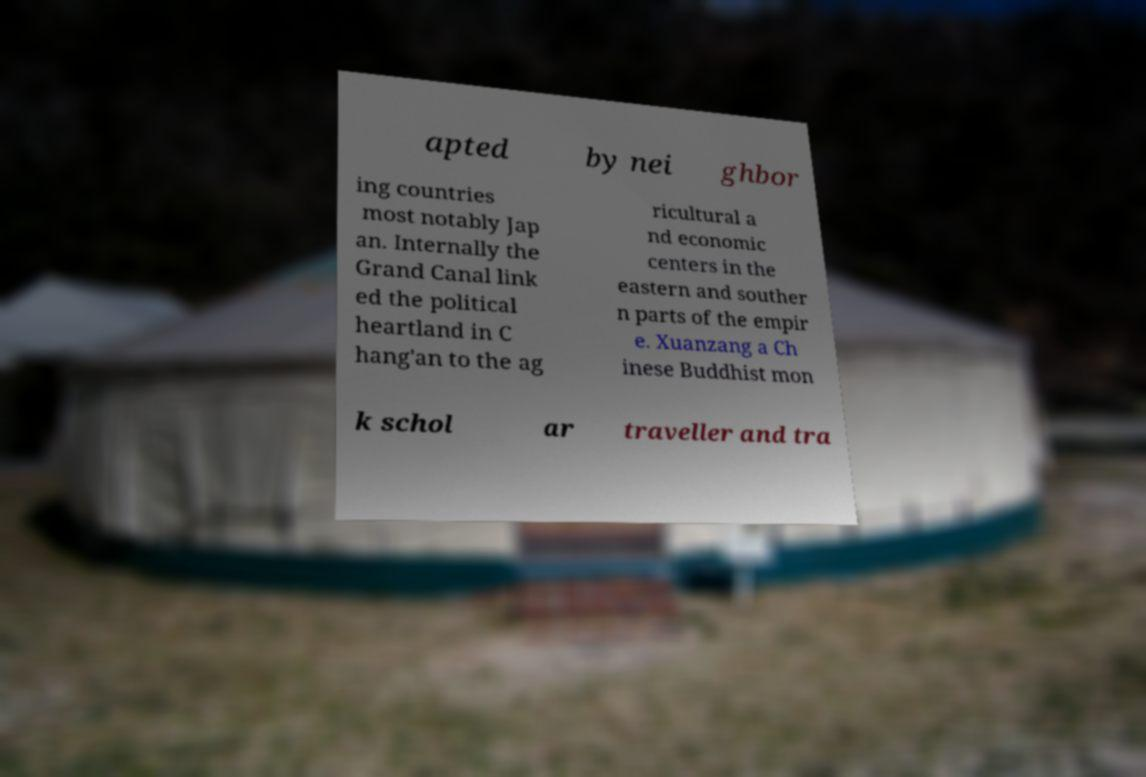There's text embedded in this image that I need extracted. Can you transcribe it verbatim? apted by nei ghbor ing countries most notably Jap an. Internally the Grand Canal link ed the political heartland in C hang'an to the ag ricultural a nd economic centers in the eastern and souther n parts of the empir e. Xuanzang a Ch inese Buddhist mon k schol ar traveller and tra 